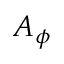<formula> <loc_0><loc_0><loc_500><loc_500>A _ { \phi }</formula> 